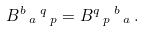<formula> <loc_0><loc_0><loc_500><loc_500>B ^ { b } \, _ { a } \, ^ { q } \, _ { p } = B ^ { q } \, _ { p } \, ^ { b } \, _ { a } \, .</formula> 